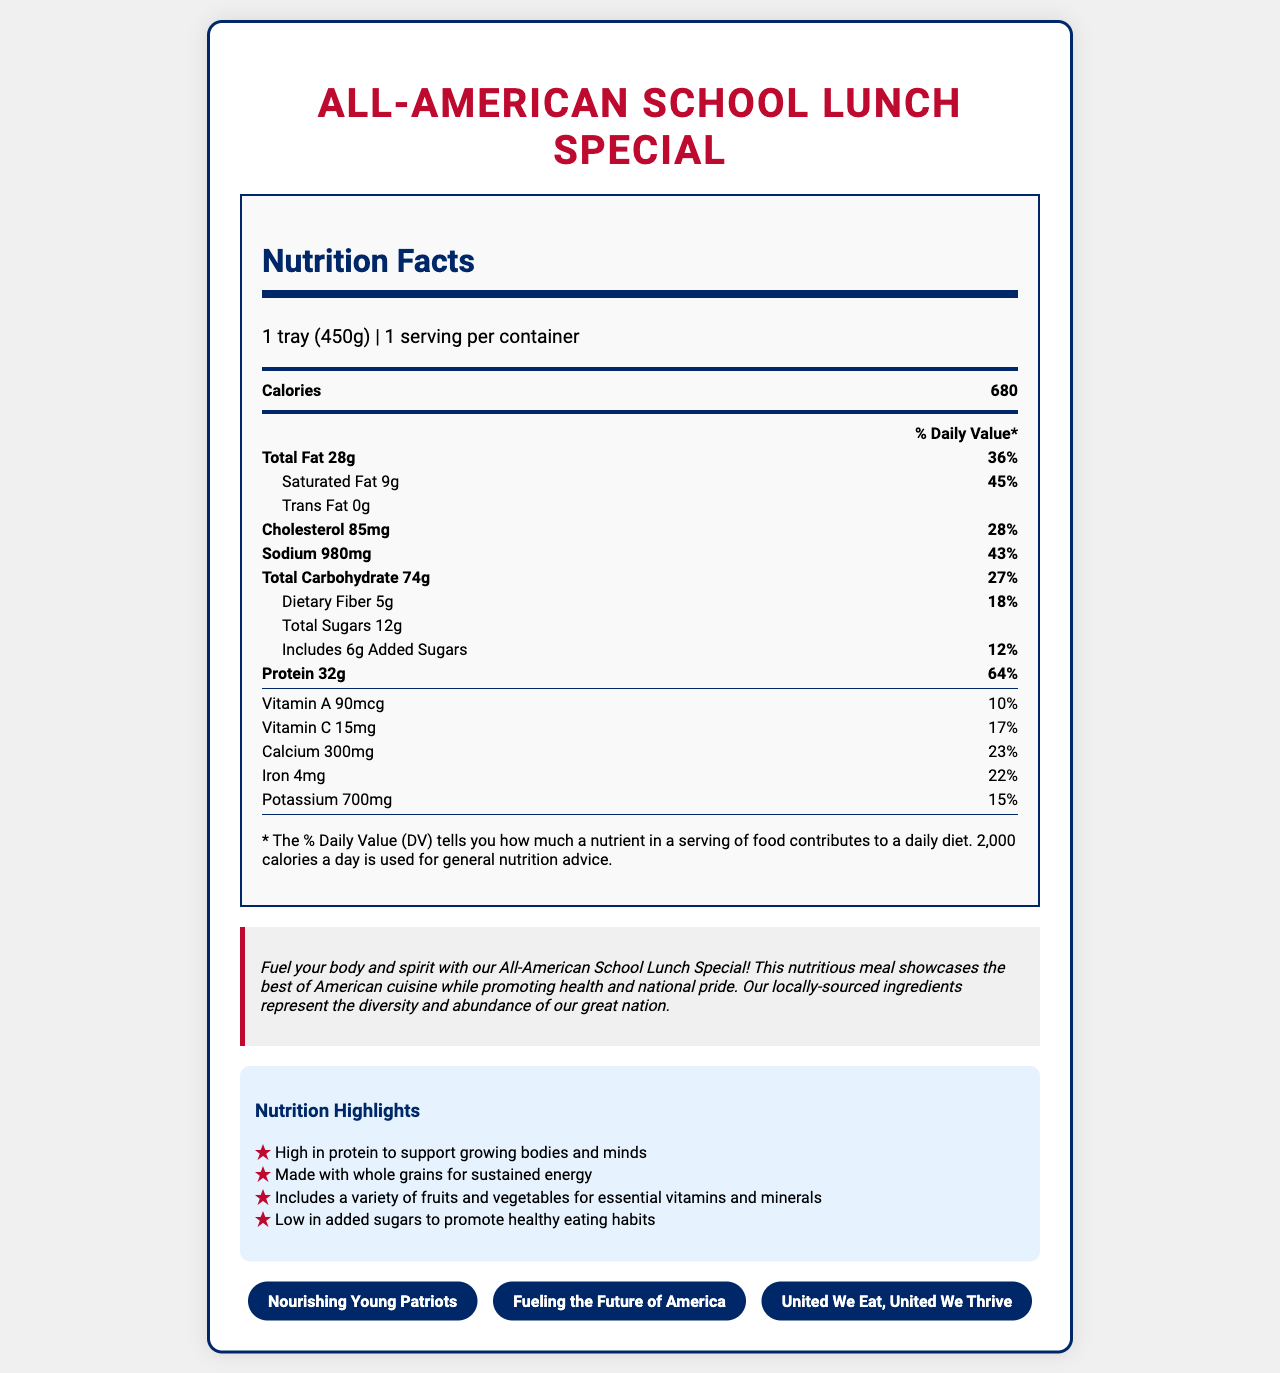what is the serving size of the All-American School Lunch Special? The serving size is clearly mentioned in the serving information section of the document as "1 tray (450g)".
Answer: 1 tray (450g) how many calories are in one serving of this school lunch? The calories per serving are listed right after the serving information and bolded as 680.
Answer: 680 what is the daily value percentage of saturated fat in one serving? The document states that the saturated fat content is 9g, which equates to 45% of the daily value.
Answer: 45% how much protein does this meal provide per serving? The protein amount is listed as 32g and the daily value percentage is 64%.
Answer: 32g which allergens are present in the All-American School Lunch Special? The allergens are listed in the allergens section as "Wheat", "Milk", and "Eggs".
Answer: Wheat, Milk, Eggs what are the main ingredients in the All-American School Lunch Special? A. Fried chicken B. Whole grain bread, Grilled chicken breast, American cheese, Lettuce, Tomato C. Pasta and Meatballs D. Rice and Beans The ingredients are listed as "Whole grain bread, Grilled chicken breast, American cheese, Lettuce, Tomato, Mayonnaise, Apple slices, Baked potato chips, Low-fat milk".
Answer: B how much dietary fiber is provided in one serving? The dietary fiber amount is listed in the nutrient row for total carbohydrates as 5g.
Answer: 5g what is the daily value percentage of sodium? A. 10% B. 20% C. 43% D. 85% The sodium content is listed as 980mg, which represents 43% of the daily value.
Answer: C does this meal include any added sugars? The document states that the meal includes 6g of added sugars, which is 12% of the daily value.
Answer: Yes summarize the main idea of the All-American School Lunch Special document. The document offers a comprehensive view of the nutritional values and patriotic theme of the lunch special, emphasizing its benefits for growing bodies and minds as well as national pride.
Answer: The All-American School Lunch Special document provides a detailed nutritional breakdown of a school lunch featuring American classics. It highlights the serving size, calorie content, amounts and daily values for various nutrients, and ingredients. The meal is promoted as nutritious and patriotic, emphasizing its use of locally-sourced ingredients representing the diversity and abundance of America. Patriotic slogans and highlights on nutritional benefits such as high protein content and low added sugars are also included. how much vitamin A does one serving provide? The amount of vitamin A is listed as 90mcg, which is 10% of the daily value.
Answer: 90 mcg how does the document describe the All-American School Lunch Special in patriotic terms? The description emphasizes the meal as not only nutritious but also a symbol of national pride, using locally-sourced ingredients to showcase America's diversity and abundance.
Answer: Fuel your body and spirit with our All-American School Lunch Special! This nutritious meal showcases the best of American cuisine while promoting health and national pride. Our locally-sourced ingredients represent the diversity and abundance of our great nation. what is the percentage of the daily value for calcium? The document lists the calcium content as 300mg, which is 23% of the daily value.
Answer: 23% how much cholesterol does one serving contain? The cholesterol content is listed as 85mg, which is 28% of the daily value.
Answer: 85mg are there any artificial sweeteners listed in the ingredients? The document does not mention whether there are any artificial sweeteners, so it cannot be determined from the information provided.
Answer: Cannot be determined 